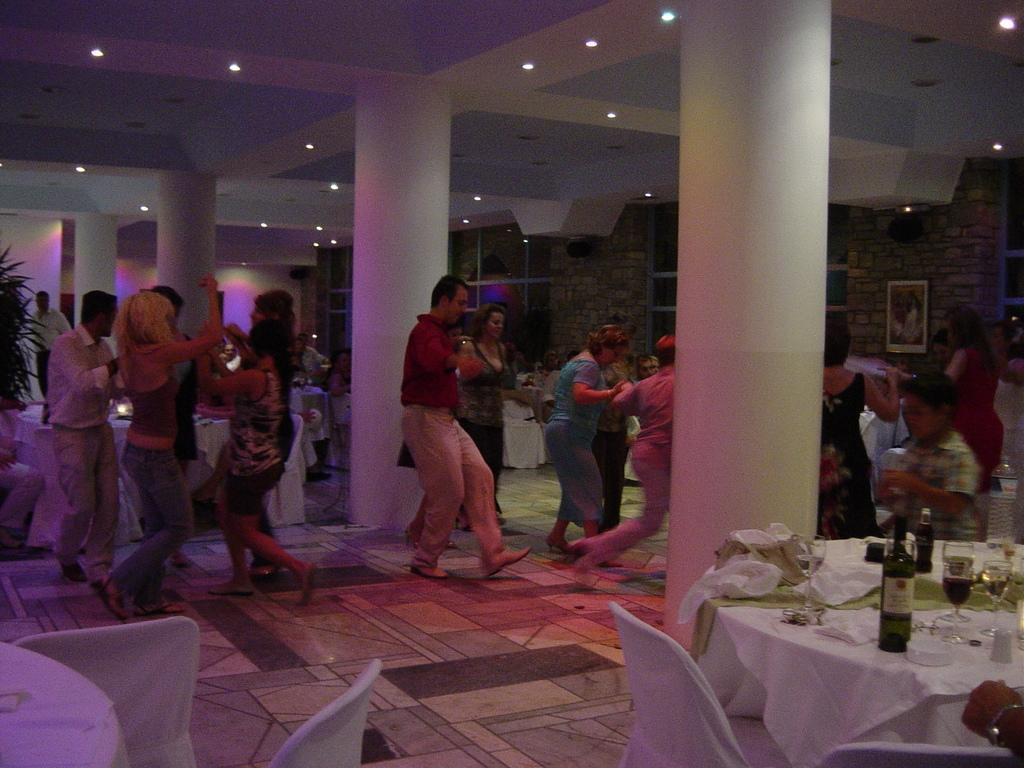Describe this image in one or two sentences. In this image we can see people are dancing. Picture is on the wall. We can see chairs, tables, plant, pillars, windows, ceiling lights and wall. Above the tables there are bottles, glasses and things. 